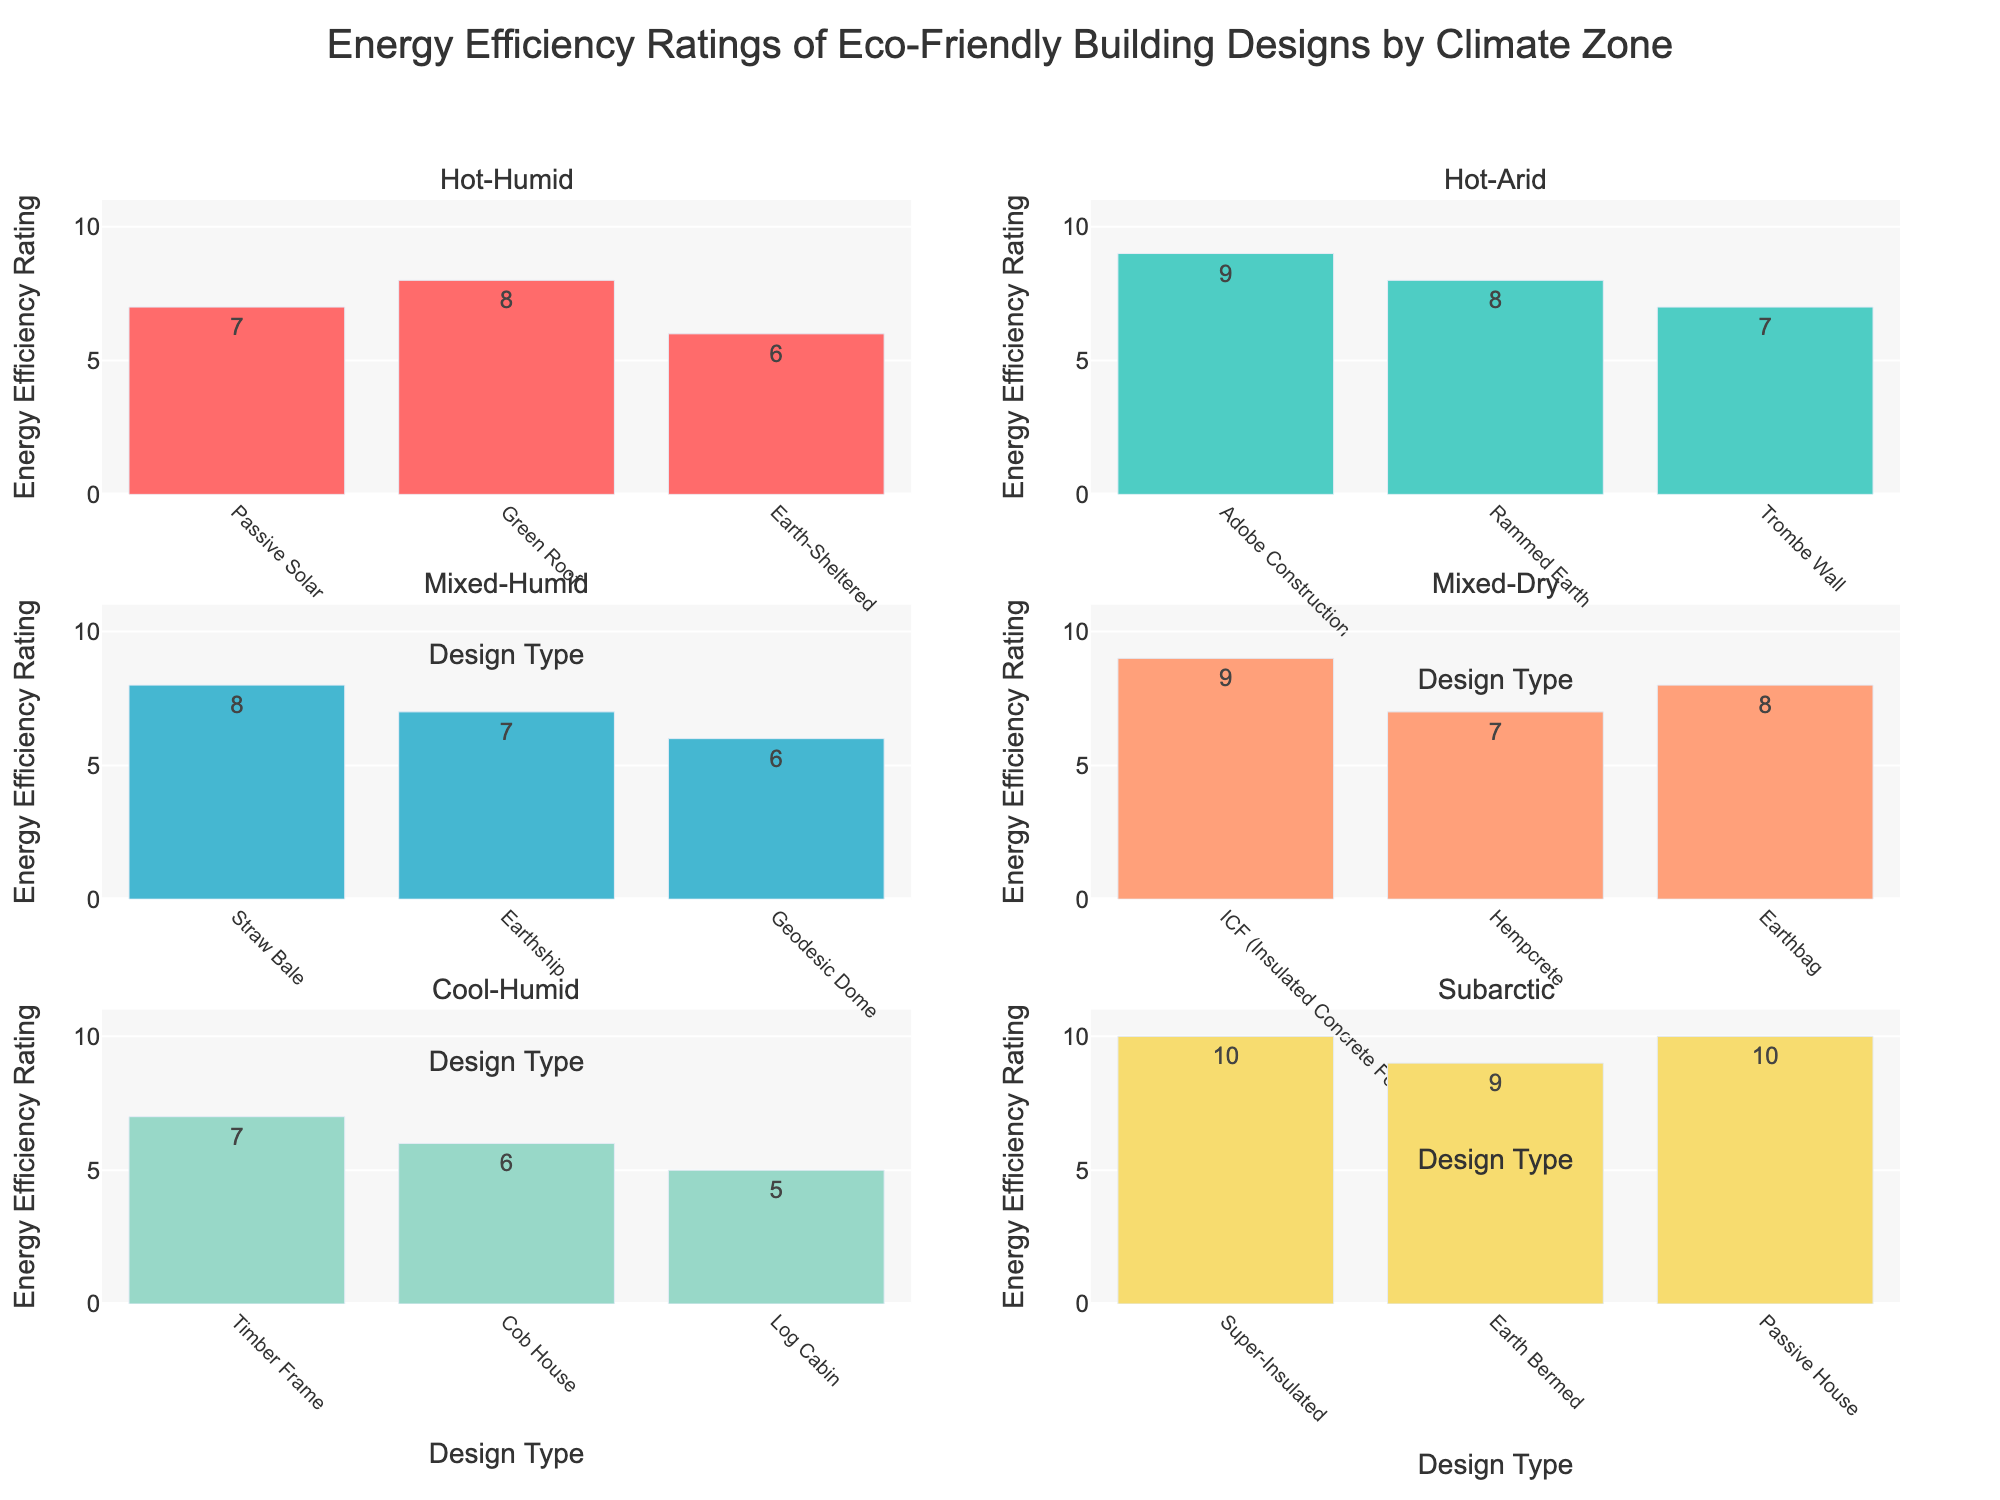What is the highest energy efficiency rating in the Hot-Arid climate zone? Locate the Hot-Arid subplot, identify the bar with the maximum height, and refer to the text or hover text for the exact value. The highest rating for the Hot-Arid climate zone is for Adobe Construction, which has a rating of 9.
Answer: 9 Which climate zone has a building design with a perfect energy efficiency rating of 10? Find the bars representing a rating of 10 across all the subplots. Only the Subarctic climate zone has bars reaching the highest possible rating of 10; these are the Super-Insulated and Passive House designs.
Answer: Subarctic How many building designs in Mixed-Humid climate zone have an energy efficiency rating of 7 or higher? Count the bars in the Mixed-Humid subplot that have a height indicating a rating greater than or equal to 7. Each rating can be checked using text position or hover text for accuracy. Straw Bale and Earthship have ratings of 8 and 7, respectively.
Answer: 2 Which design type in the Cool-Humid climate zone has the lowest energy efficiency rating? Check the Cool-Humid subplot, identify the smallest bar in terms of height, and refer to the text or hover text for the exact value. The Log Cabin has the lowest rating of 5.
Answer: Log Cabin Is there any design type in the Subarctic climate zone with a rating less than 9? Analyze the Subarctic subplot and observe the bars, primarily focusing on those with less height compared to a rating of 9. The Earth Bermed design has a rating of 9, and both Super-Insulated and Passive House have a rating of 10, so there is no bar with a rating less than 9.
Answer: No Which climate zone shows the most consistent energy efficiency ratings among its design types? Compare the spread of ratings within each climate zone by observing the range between the highest and lowest bars. The Subarctic climate zone shows more consistency with ratings of 9 and 10, suggesting less variation.
Answer: Subarctic Between the Hot-Humid and Mixed-Dry climate zones, which one has higher average energy efficiency ratings? Calculate the average rating for both zones:
For Hot-Humid: (7 + 8 + 6) / 3 = 7
For Mixed-Dry: (9 + 7 + 8) / 3 = 8
The Mixed-Dry climate zone has the higher average rating.
Answer: Mixed-Dry What is the total number of building design types shown in the figure? Count all the unique bars in each subplot and sum them up. Each climate zone has 3 design types, and with 6 climate zones, the total is: (3 * 6) = 18
Answer: 18 